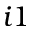Convert formula to latex. <formula><loc_0><loc_0><loc_500><loc_500>i 1</formula> 